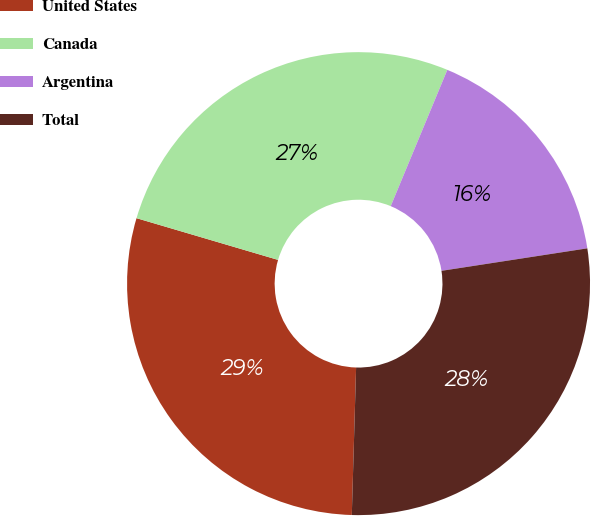<chart> <loc_0><loc_0><loc_500><loc_500><pie_chart><fcel>United States<fcel>Canada<fcel>Argentina<fcel>Total<nl><fcel>29.1%<fcel>26.7%<fcel>16.3%<fcel>27.9%<nl></chart> 